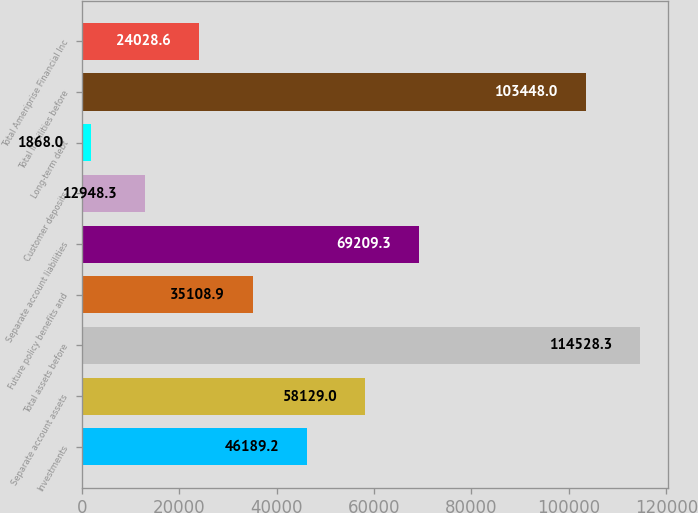Convert chart to OTSL. <chart><loc_0><loc_0><loc_500><loc_500><bar_chart><fcel>Investments<fcel>Separate account assets<fcel>Total assets before<fcel>Future policy benefits and<fcel>Separate account liabilities<fcel>Customer deposits<fcel>Long-term debt<fcel>Total liabilities before<fcel>Total Ameriprise Financial Inc<nl><fcel>46189.2<fcel>58129<fcel>114528<fcel>35108.9<fcel>69209.3<fcel>12948.3<fcel>1868<fcel>103448<fcel>24028.6<nl></chart> 